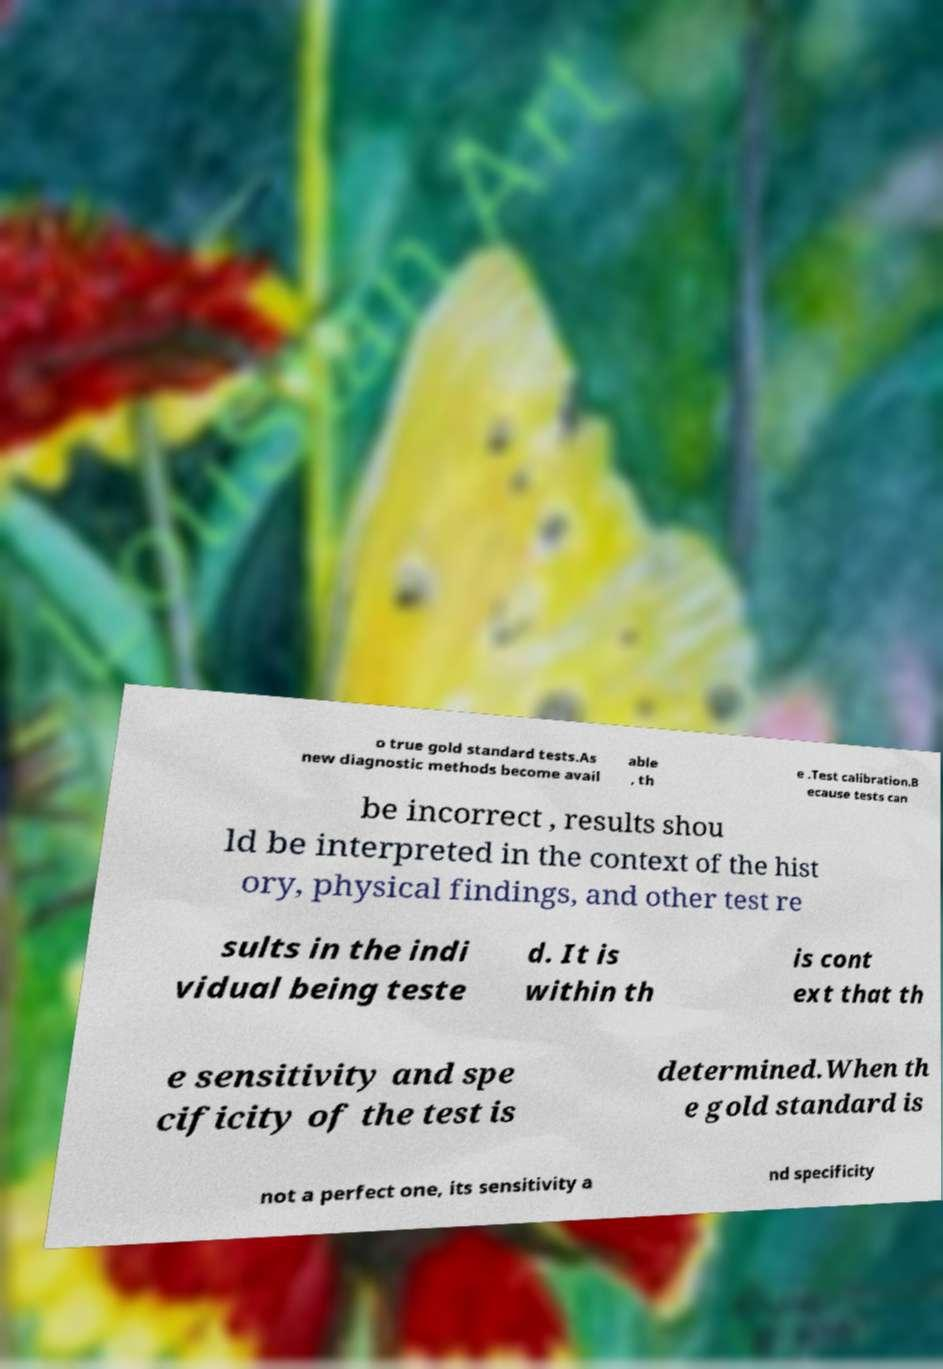There's text embedded in this image that I need extracted. Can you transcribe it verbatim? o true gold standard tests.As new diagnostic methods become avail able , th e .Test calibration.B ecause tests can be incorrect , results shou ld be interpreted in the context of the hist ory, physical findings, and other test re sults in the indi vidual being teste d. It is within th is cont ext that th e sensitivity and spe cificity of the test is determined.When th e gold standard is not a perfect one, its sensitivity a nd specificity 